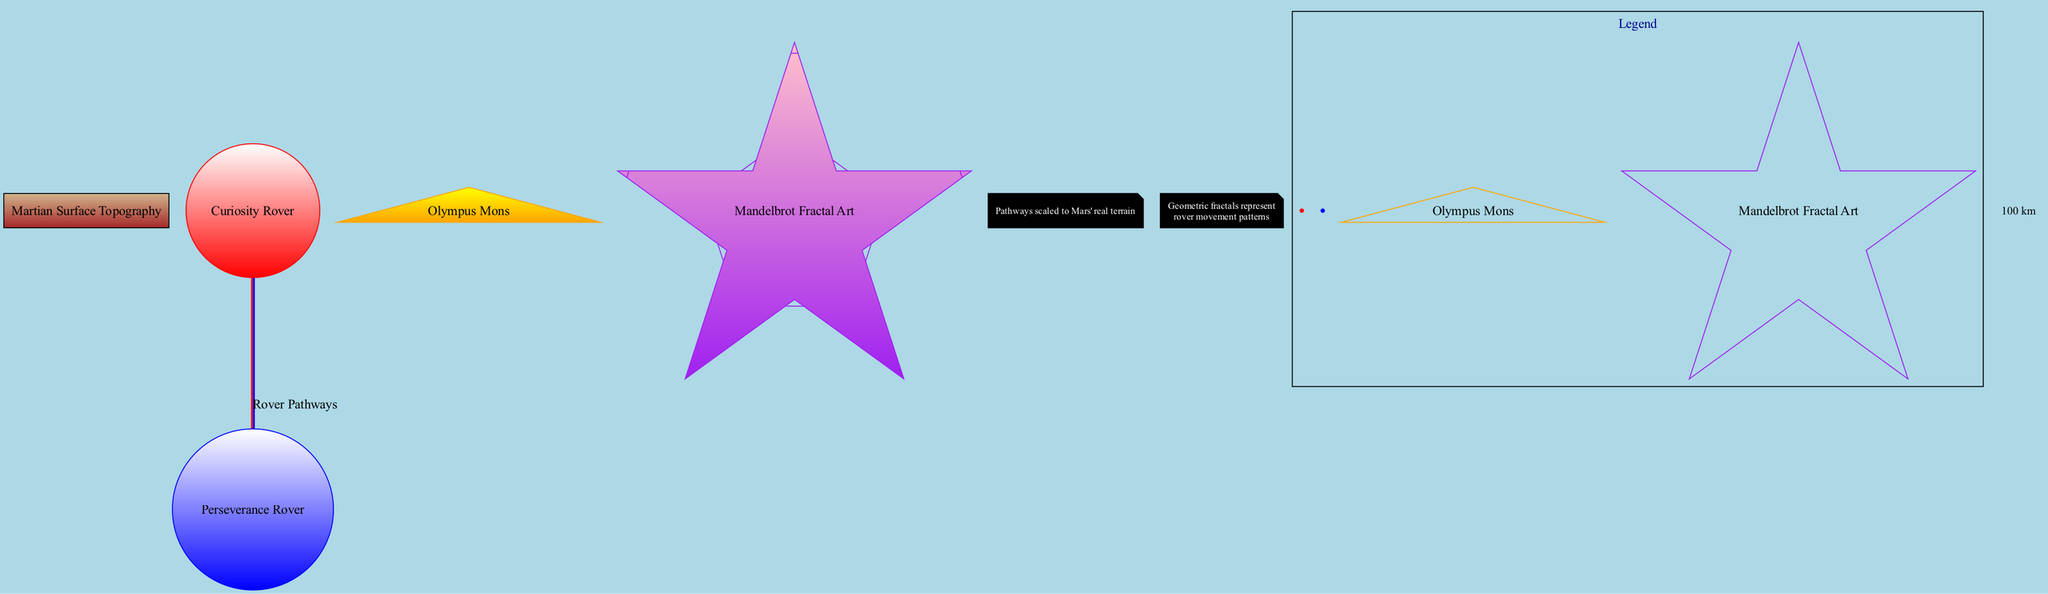What is the color of the Curiosity Rover pathway? The Curiosity Rover pathway is represented as a solid line in red according to the diagram legend.
Answer: red What type of art is displayed on the map? The diagram includes Mandelbrot Fractal Art, as indicated by the labeled section containing fractal patterns.
Answer: Mandelbrot Fractal Art Where is Olympus Mons located? Olympus Mons is represented by an orange circle at the coordinate point 18.65, 226.2 on the map, confirming its location.
Answer: 18.65, 226.2 How many pathways are represented in the diagram? There are two pathways shown in the diagram: one for the Curiosity Rover and another for the Perseverance Rover, making the total two.
Answer: 2 What style is used for the Perseverance Rover pathway? The Perseverance Rover pathway is depicted using a dashed line style in the legend, indicating its visual representation.
Answer: dashed Which color indicates the pathway of the Perseverance Rover? The pathway of the Perseverance Rover is shown in blue as specified in the diagram's legend section.
Answer: blue What do the geometric fractals on the map depict? The geometric fractals symbolize the movement patterns of the rovers as noted in the diagram annotations, linking art to rover paths.
Answer: rover movement patterns What is the indicated scale measurement unit on the map? The scale of the diagram specifies the unit of measurement as kilometers, which is critical for understanding the displayed distances accurately.
Answer: km What is the annotation caption for the scaled pathways? The annotation caption reads "Pathways scaled to Mars' real terrain," which provides context for the representation of actual rover paths in the map.
Answer: Pathways scaled to Mars' real terrain 